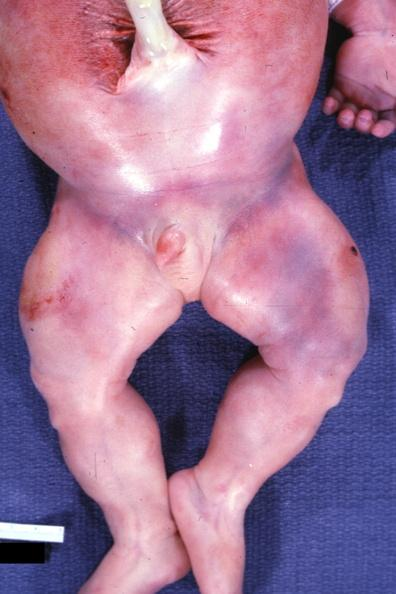does this image show lower extremities with increased muscle mass several other slides?
Answer the question using a single word or phrase. Yes 